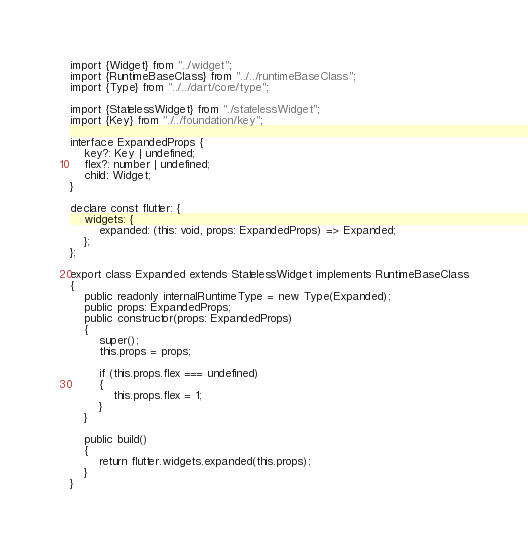<code> <loc_0><loc_0><loc_500><loc_500><_TypeScript_>import {Widget} from "../widget";
import {RuntimeBaseClass} from "../../runtimeBaseClass";
import {Type} from "../../dart/core/type";

import {StatelessWidget} from "./statelessWidget";
import {Key} from "./../foundation/key";

interface ExpandedProps {
    key?: Key | undefined;
    flex?: number | undefined;
    child: Widget;
}

declare const flutter: {
    widgets: {
        expanded: (this: void, props: ExpandedProps) => Expanded;
    };
};

export class Expanded extends StatelessWidget implements RuntimeBaseClass
{
    public readonly internalRuntimeType = new Type(Expanded);
    public props: ExpandedProps;
    public constructor(props: ExpandedProps) 
    {
        super();
        this.props = props;

        if (this.props.flex === undefined) 
        {
            this.props.flex = 1;
        }
    }

    public build() 
    {
        return flutter.widgets.expanded(this.props);
    }
}</code> 